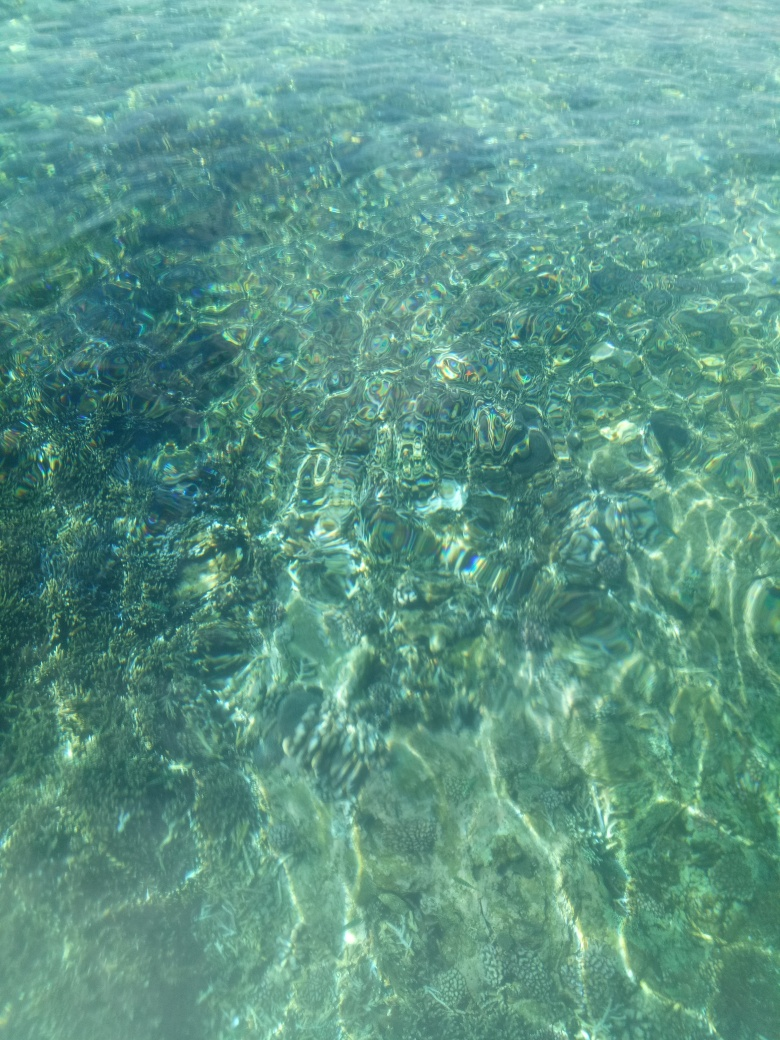Is the image lacking in contrast? No, the image is not lacking in contrast. The clarity of the water allows for the distinction between light and shadows, revealing a textured underwater landscape. Variation in the blues and greens, as well as the refracted sunlight patterns, contribute to a striking visual with ample contrast. 